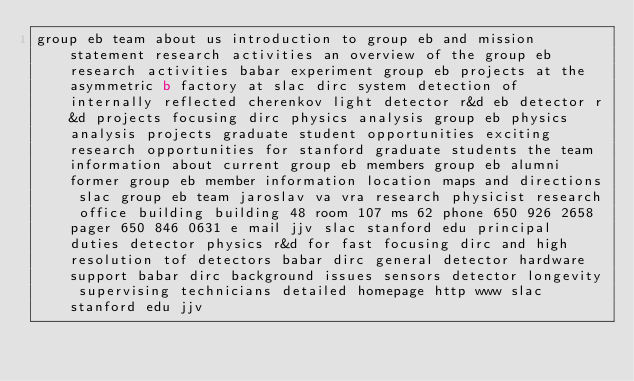<code> <loc_0><loc_0><loc_500><loc_500><_HTML_>group eb team about us introduction to group eb and mission statement research activities an overview of the group eb research activities babar experiment group eb projects at the asymmetric b factory at slac dirc system detection of internally reflected cherenkov light detector r&d eb detector r&d projects focusing dirc physics analysis group eb physics analysis projects graduate student opportunities exciting research opportunities for stanford graduate students the team information about current group eb members group eb alumni former group eb member information location maps and directions slac group eb team jaroslav va vra research physicist research office building building 48 room 107 ms 62 phone 650 926 2658 pager 650 846 0631 e mail jjv slac stanford edu principal duties detector physics r&d for fast focusing dirc and high resolution tof detectors babar dirc general detector hardware support babar dirc background issues sensors detector longevity supervising technicians detailed homepage http www slac stanford edu jjv
</code> 